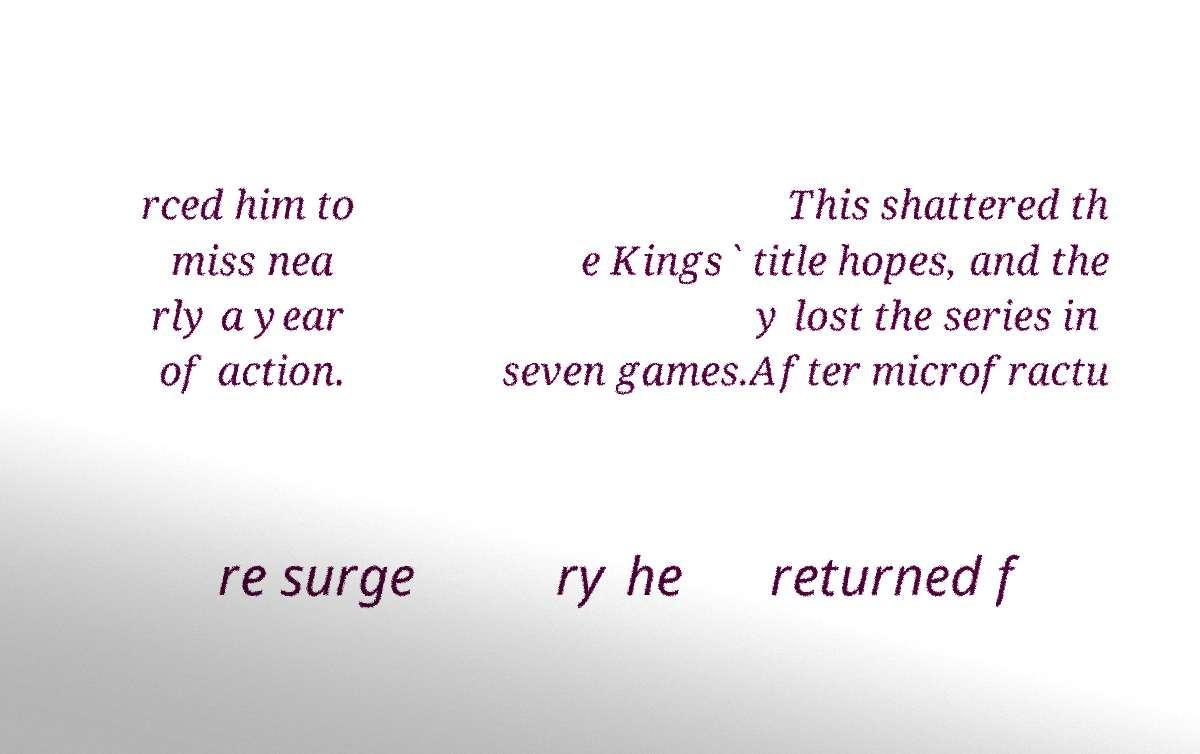Can you accurately transcribe the text from the provided image for me? rced him to miss nea rly a year of action. This shattered th e Kings` title hopes, and the y lost the series in seven games.After microfractu re surge ry he returned f 